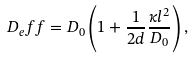Convert formula to latex. <formula><loc_0><loc_0><loc_500><loc_500>D _ { e } f f = D _ { 0 } \left ( 1 + \frac { 1 } { 2 d } \frac { \kappa l ^ { 2 } } { D _ { 0 } } \right ) ,</formula> 